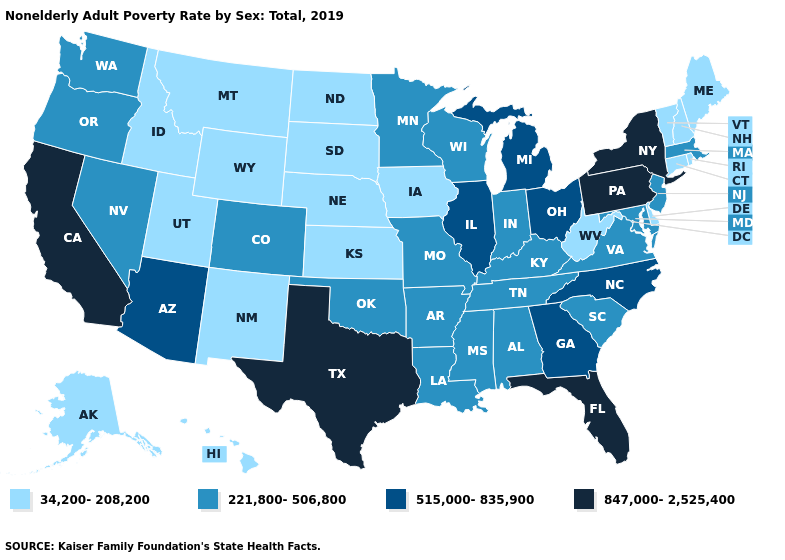What is the value of Colorado?
Short answer required. 221,800-506,800. What is the value of Iowa?
Be succinct. 34,200-208,200. Name the states that have a value in the range 221,800-506,800?
Keep it brief. Alabama, Arkansas, Colorado, Indiana, Kentucky, Louisiana, Maryland, Massachusetts, Minnesota, Mississippi, Missouri, Nevada, New Jersey, Oklahoma, Oregon, South Carolina, Tennessee, Virginia, Washington, Wisconsin. Name the states that have a value in the range 515,000-835,900?
Short answer required. Arizona, Georgia, Illinois, Michigan, North Carolina, Ohio. What is the lowest value in the West?
Be succinct. 34,200-208,200. Does Iowa have the highest value in the USA?
Concise answer only. No. What is the lowest value in the USA?
Short answer required. 34,200-208,200. What is the lowest value in the USA?
Give a very brief answer. 34,200-208,200. Does Michigan have a higher value than North Carolina?
Answer briefly. No. What is the value of Vermont?
Be succinct. 34,200-208,200. Does New Mexico have the highest value in the USA?
Short answer required. No. What is the value of Maryland?
Concise answer only. 221,800-506,800. Name the states that have a value in the range 34,200-208,200?
Answer briefly. Alaska, Connecticut, Delaware, Hawaii, Idaho, Iowa, Kansas, Maine, Montana, Nebraska, New Hampshire, New Mexico, North Dakota, Rhode Island, South Dakota, Utah, Vermont, West Virginia, Wyoming. Is the legend a continuous bar?
Write a very short answer. No. 